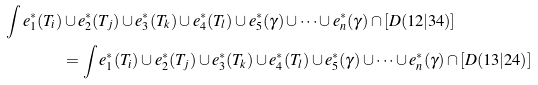<formula> <loc_0><loc_0><loc_500><loc_500>\int e _ { 1 } ^ { * } ( T _ { i } ) & \cup e _ { 2 } ^ { * } ( T _ { j } ) \cup e _ { 3 } ^ { * } ( T _ { k } ) \cup e _ { 4 } ^ { * } ( T _ { l } ) \cup e _ { 5 } ^ { * } ( \gamma ) \cup \dots \cup e _ { n } ^ { * } ( \gamma ) \cap [ D ( 1 2 | 3 4 ) ] \\ & = \int e _ { 1 } ^ { * } ( T _ { i } ) \cup e _ { 2 } ^ { * } ( T _ { j } ) \cup e _ { 3 } ^ { * } ( T _ { k } ) \cup e _ { 4 } ^ { * } ( T _ { l } ) \cup e _ { 5 } ^ { * } ( \gamma ) \cup \dots \cup e _ { n } ^ { * } ( \gamma ) \cap [ D ( 1 3 | 2 4 ) ]</formula> 